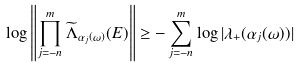Convert formula to latex. <formula><loc_0><loc_0><loc_500><loc_500>\log \left \| \prod _ { j = - n } ^ { m } \widetilde { \Lambda } _ { \alpha _ { j } ( \omega ) } ( E ) \right \| \geq - \sum _ { j = - n } ^ { m } \log | \lambda _ { + } ( \alpha _ { j } ( \omega ) ) |</formula> 